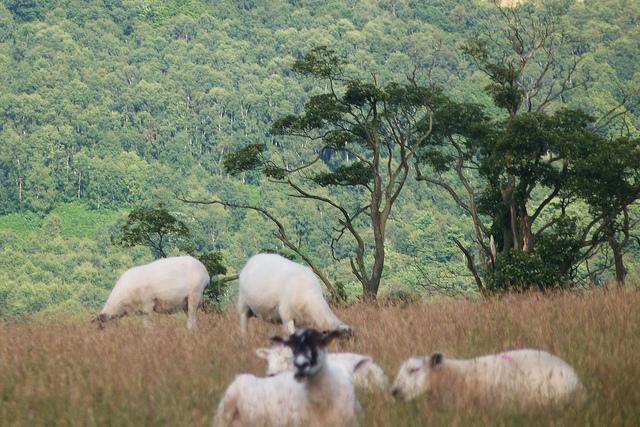How many animals are standing in the dry grass?
Give a very brief answer. 5. How many sheep can you see?
Give a very brief answer. 5. How many people are wearing red?
Give a very brief answer. 0. 